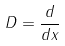<formula> <loc_0><loc_0><loc_500><loc_500>D = \frac { d } { d x }</formula> 